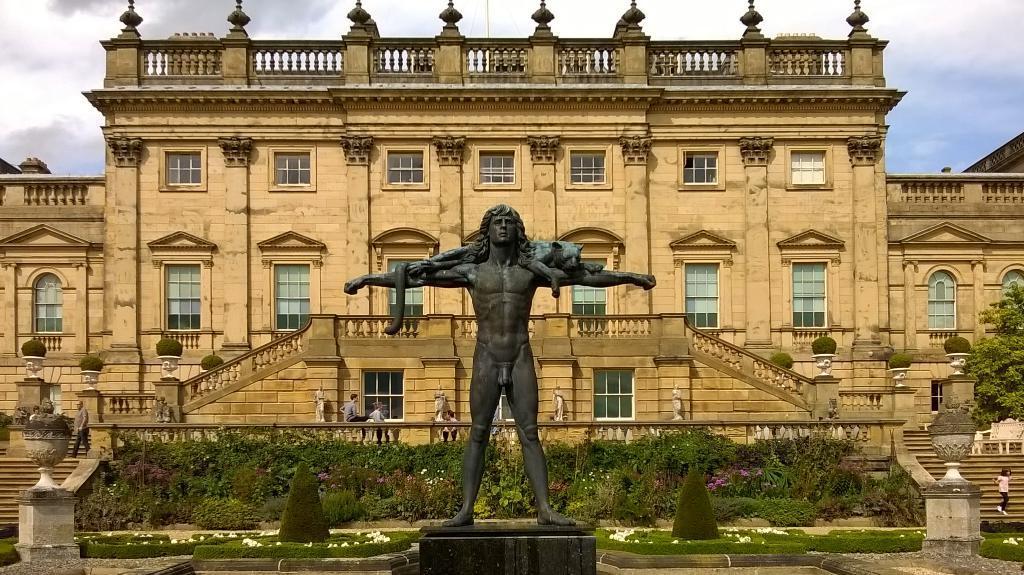Could you give a brief overview of what you see in this image? In this picture I see a statue in front and in the background I see a buildings and number of plants and I see few people and I see the sky which is a bit cloudy and I see a tree on the right side of this image. 